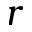Convert formula to latex. <formula><loc_0><loc_0><loc_500><loc_500>r</formula> 